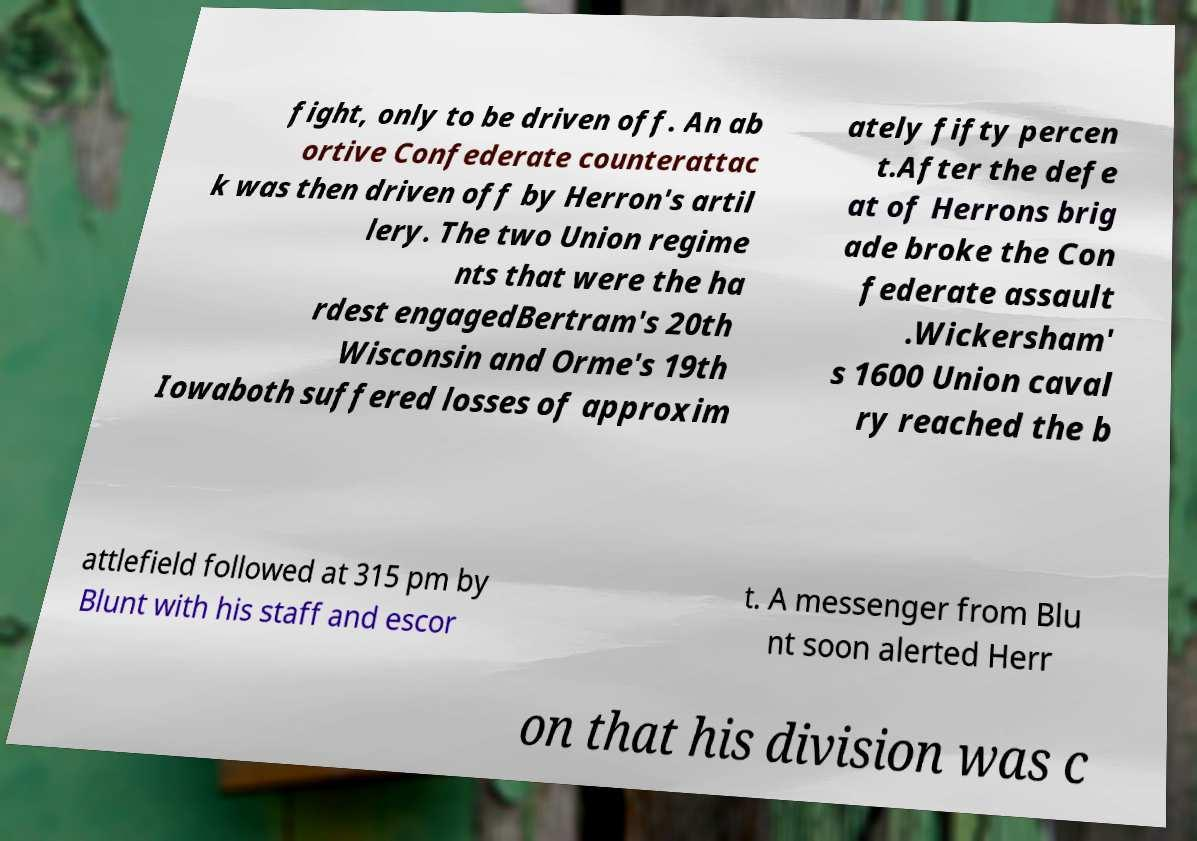I need the written content from this picture converted into text. Can you do that? fight, only to be driven off. An ab ortive Confederate counterattac k was then driven off by Herron's artil lery. The two Union regime nts that were the ha rdest engagedBertram's 20th Wisconsin and Orme's 19th Iowaboth suffered losses of approxim ately fifty percen t.After the defe at of Herrons brig ade broke the Con federate assault .Wickersham' s 1600 Union caval ry reached the b attlefield followed at 315 pm by Blunt with his staff and escor t. A messenger from Blu nt soon alerted Herr on that his division was c 